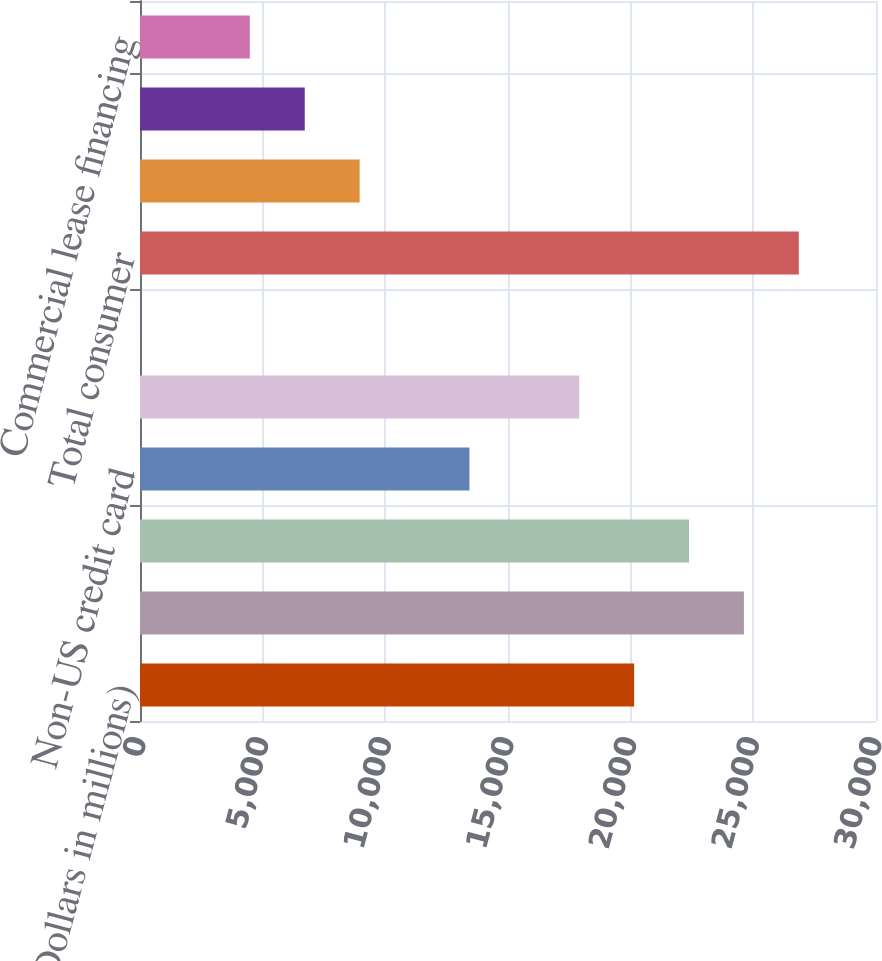Convert chart to OTSL. <chart><loc_0><loc_0><loc_500><loc_500><bar_chart><fcel>(Dollars in millions)<fcel>Residential mortgage (2)<fcel>US credit card<fcel>Non-US credit card<fcel>Direct/Indirect consumer<fcel>Other consumer<fcel>Total consumer<fcel>US commercial (3)<fcel>Commercial real estate<fcel>Commercial lease financing<nl><fcel>20141.3<fcel>24616.7<fcel>22379<fcel>13428.2<fcel>17903.6<fcel>2<fcel>26854.4<fcel>8952.8<fcel>6715.1<fcel>4477.4<nl></chart> 